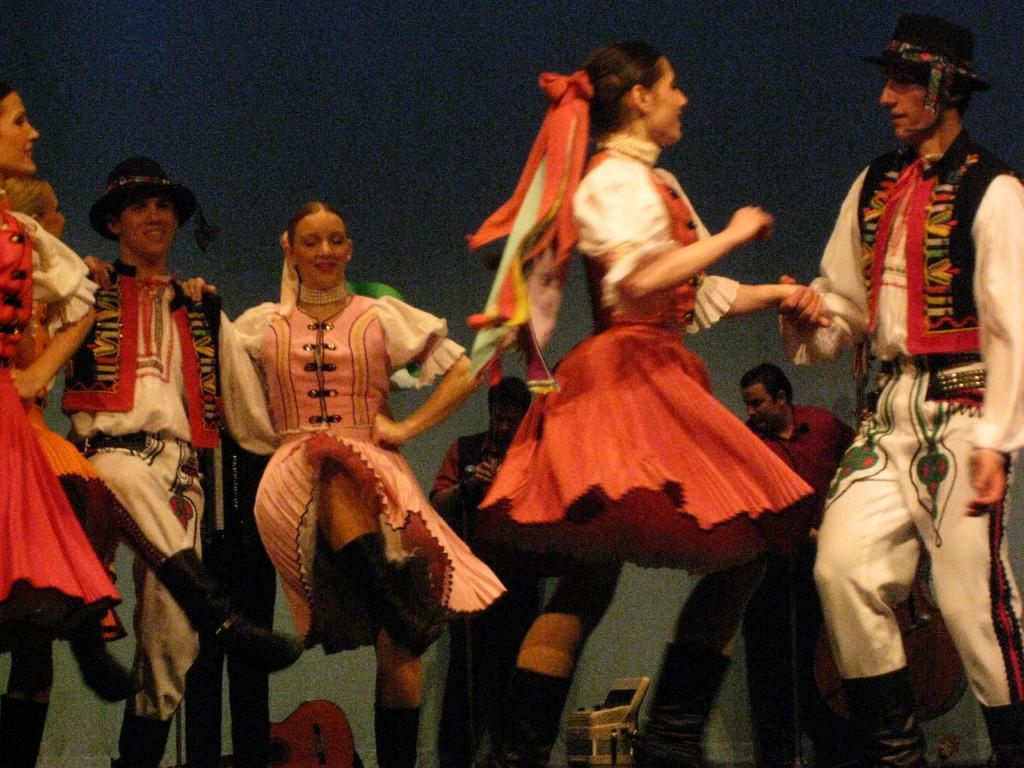In one or two sentences, can you explain what this image depicts? There are few men and women dancing. Men are wearing hats. In the back there is a wall. Also there are two persons standing. There is a guitar and and some other thing in the background. 